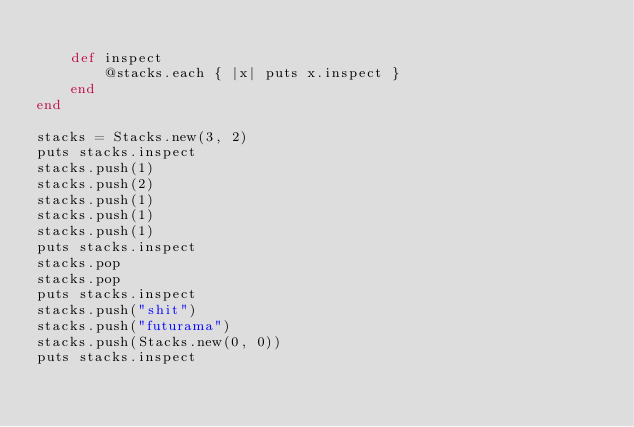<code> <loc_0><loc_0><loc_500><loc_500><_Ruby_>
    def inspect
        @stacks.each { |x| puts x.inspect }
    end
end

stacks = Stacks.new(3, 2)
puts stacks.inspect
stacks.push(1)
stacks.push(2)
stacks.push(1)
stacks.push(1)
stacks.push(1)
puts stacks.inspect
stacks.pop
stacks.pop
puts stacks.inspect
stacks.push("shit")
stacks.push("futurama")
stacks.push(Stacks.new(0, 0))
puts stacks.inspect
</code> 